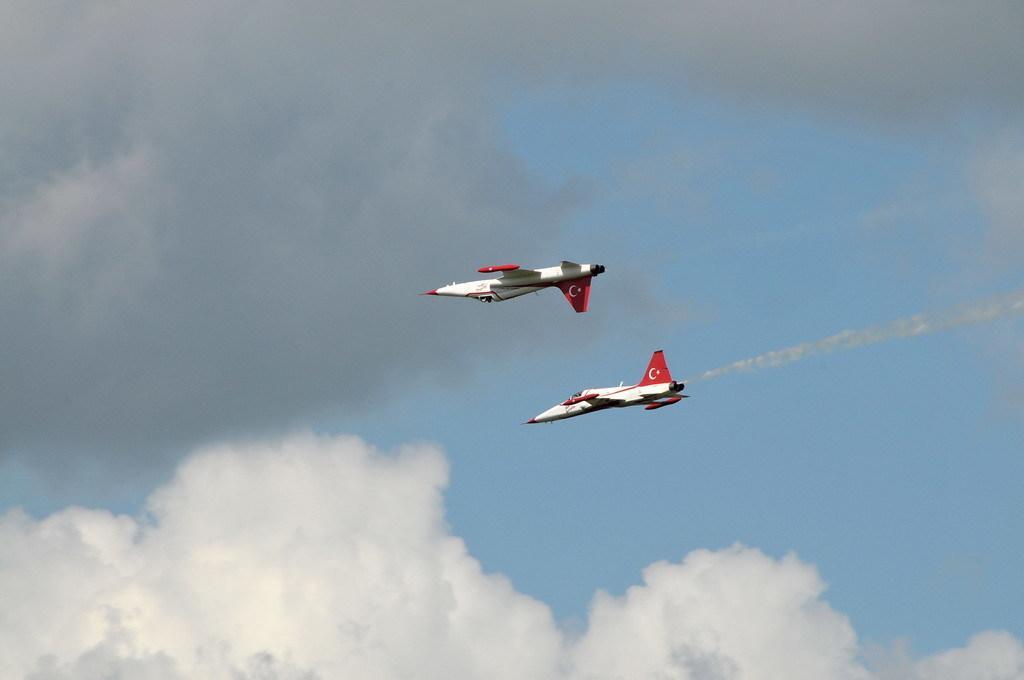In one or two sentences, can you explain what this image depicts? In this image there are two aircrafts flying in the sky. They are emitting the smoke. At the bottom there are clouds. 